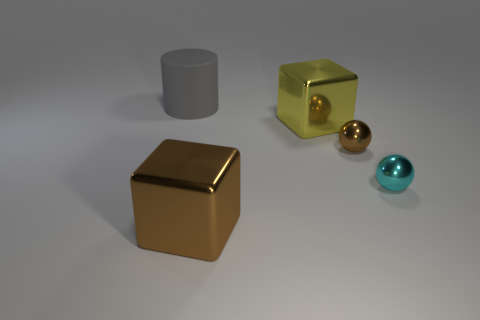How many large cylinders are behind the large cylinder? 0 